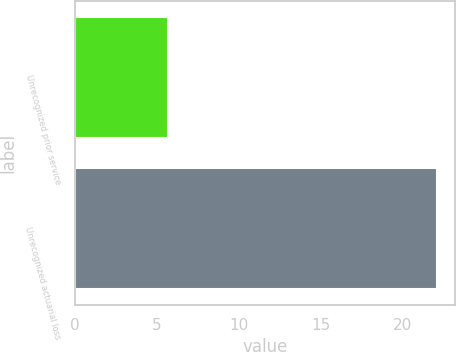<chart> <loc_0><loc_0><loc_500><loc_500><bar_chart><fcel>Unrecognized prior service<fcel>Unrecognized actuarial loss<nl><fcel>5.7<fcel>22.1<nl></chart> 